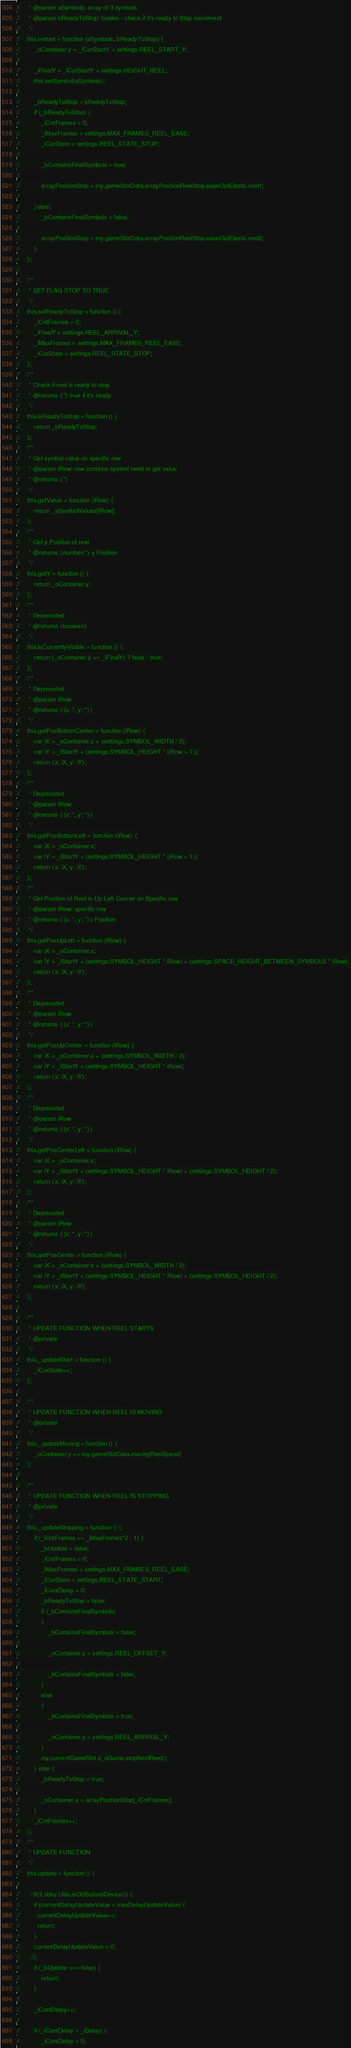<code> <loc_0><loc_0><loc_500><loc_500><_JavaScript_>//     * @param aSymbols: array of 3 symbols
//     * @param bReadyToStop: boolen - check if it's ready to Stop movement
//     */
//    this.restart = function (aSymbols, bReadyToStop) {
//        _oContainer.y = _iCurStartY = settings.REEL_START_Y;
//
//        _iFinalY = _iCurStartY + settings.HEIGHT_REEL;
//        this.setSymbol(aSymbols);
//
//        _bReadyToStop = bReadyToStop;
//        if (_bReadyToStop) {
//            _iCntFrames = 0;
//            _iMaxFrames = settings.MAX_FRAMES_REEL_EASE;
//            _iCurState = settings.REEL_STATE_STOP;
//
//            _bContainsFinalSymbols = true;
//
//            arrayPositionStop = my.gameSlotData.arrayPositionReelStop.easeOutElastic.reel1;
//
//        }else{
//            _bContainsFinalSymbols = false;
//
//            arrayPositionStop = my.gameSlotData.arrayPositionReelStop.easeOutElastic.reel2;
//        }
//    };
//
//    /**
//     * SET FLAG STOP TO TRUE
//     */
//    this.setReadyToStop = function () {
//        _iCntFrames = 0;
//        _iFinalY = settings.REEL_ARRIVAL_Y;
//        _iMaxFrames = settings.MAX_FRAMES_REEL_EASE;
//        _iCurState = settings.REEL_STATE_STOP;
//    };
//    /**
//     * Check if reel is ready to stop
//     * @returns {*} true if it's ready
//     */
//    this.isReadyToStop = function () {
//        return _bReadyToStop;
//    };
//    /**
//     * Get symbol value on specific row
//     * @param iRow: row contains symbol need to get value
//     * @returns {*}
//     */
//    this.getValue = function (iRow) {
//        return _aSymbolValues[iRow];
//    };
//    /**
//     * Get y Position of reel
//     * @returns {number|*} y Position
//     */
//    this.getY = function () {
//        return _oContainer.y;
//    };
//    /**
//     * Deprecated
//     * @returns {boolean}
//     */
//    this.isCurrentlyVisible = function () {
//        return (_oContainer.y >= _iFinalY) ? false : true;
//    };
//    /**
//     * Deprecated
//     * @param iRow
//     * @returns {{x: *, y: *}}
//     */
//    this.getPosBottomCenter = function (iRow) {
//        var iX = _oContainer.x + (settings.SYMBOL_WIDTH / 2);
//        var iY = _iStartY + (settings.SYMBOL_HEIGHT * (iRow + 1));
//        return {x: iX, y: iY};
//    };
//    /**
//     * Deprecated
//     * @param iRow
//     * @returns {{x: *, y: *}}
//     */
//    this.getPosBottomLeft = function (iRow) {
//        var iX = _oContainer.x;
//        var iY = _iStartY + (settings.SYMBOL_HEIGHT * (iRow + 1));
//        return {x: iX, y: iY};
//    };
//    /**
//     * Get Position of Reel in Up Left Conner on Specific row
//     * @param iRow: specific row
//     * @returns {{x: *, y: *}} Position
//     */
//    this.getPosUpLeft = function (iRow) {
//        var iX = _oContainer.x;
//        var iY = _iStartY + (settings.SYMBOL_HEIGHT * iRow) + (settings.SPACE_HEIGHT_BETWEEN_SYMBOLS * iRow);
//        return {x: iX, y: iY};
//    };
//    /**
//     * Deprecated
//     * @param iRow
//     * @returns {{x: *, y: *}}
//     */
//    this.getPosUpCenter = function (iRow) {
//        var iX = _oContainer.x + (settings.SYMBOL_WIDTH / 2);
//        var iY = _iStartY + (settings.SYMBOL_HEIGHT * iRow);
//        return {x: iX, y: iY};
//    };
//    /**
//     * Deprecated
//     * @param iRow
//     * @returns {{x: *, y: *}}
//     */
//    this.getPosCenterLeft = function (iRow) {
//        var iX = _oContainer.x;
//        var iY = _iStartY + (settings.SYMBOL_HEIGHT * iRow) + (settings.SYMBOL_HEIGHT / 2);
//        return {x: iX, y: iY};
//    };
//    /**
//     * Deprecated
//     * @param iRow
//     * @returns {{x: *, y: *}}
//     */
//    this.getPosCenter = function (iRow) {
//        var iX = _oContainer.x + (settings.SYMBOL_WIDTH / 2);
//        var iY = _iStartY + (settings.SYMBOL_HEIGHT * iRow) + (settings.SYMBOL_HEIGHT / 2);
//        return {x: iX, y: iY};
//    };
//
//    /**
//     * UPDATE FUNCTION WHEN REEL STARTS
//     * @private
//     */
//    this._updateStart = function () {
//        _iCurState++;
//    };
//
//    /**
//     * UPDATE FUNCTION WHEN REEL IS MOVING
//     * @private
//     */
//    this._updateMoving = function () {
//        _oContainer.y += my.gameSlotData.movingReelSpeed;
//    };
//
//    /**
//     * UPDATE FUNCTION WHEN REEL IS STOPPING
//     * @private
//     */
//    this._updateStopping = function () {
//        if (_iCntFrames >= _iMaxFrames*2 - 1) {
//            _bUpdate = false;
//            _iCntFrames = 0;
//            _iMaxFrames = settings.MAX_FRAMES_REEL_EASE;
//            _iCurState = settings.REEL_STATE_START;
//            _iContDelay = 0;
//            _bReadyToStop = false;
//            if (_bContainsFinalSymbols)
//            {
//                _bContainsFinalSymbols = false;
//
//                _oContainer.y = settings.REEL_OFFSET_Y;
//
//                _bContainsFinalSymbols = false;
//            }
//            else
//            {
//                _bContainsFinalSymbols = true;
//
//                _oContainer.y = settings.REEL_ARRIVAL_Y;
//            }
//            my.currentGameSlot.s_oGame.stopNextReel();
//        } else {
//            _bReadyToStop = true;
//
//            _oContainer.y = arrayPositionStop[_iCntFrames];
//        }
//        _iCntFrames++;
//    };
//    /**
//     * UPDATE FUNCTION
//     */
//    this.update = function () {
//
//      //if(!Lobby.Utils.isOldSchoolDevice()) {
//        if (currentDelayUpdateValue < maxDelayUpdateValue) {
//          currentDelayUpdateValue++;
//          return;
//        }
//        currentDelayUpdateValue = 0;
//      //}
//        if (_bUpdate === false) {
//            return;
//        }
//
//        _iContDelay++;
//
//        if (_iContDelay > _iDelay) {
//            _iContDelay = 0;</code> 